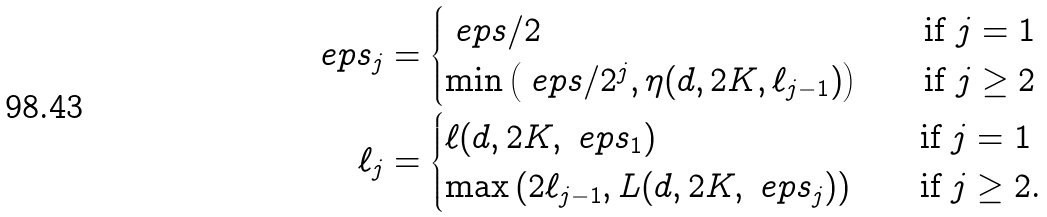Convert formula to latex. <formula><loc_0><loc_0><loc_500><loc_500>\ e p s _ { j } & = \begin{cases} \ e p s / 2 & \quad \text {if $j=1$} \\ \min \left ( \ e p s / 2 ^ { j } , \eta ( d , 2 K , \ell _ { j - 1 } ) \right ) & \quad \text {if $j\geq 2$} \end{cases} \\ \ell _ { j } & = \begin{cases} \ell ( d , 2 K , \ e p s _ { 1 } ) & \quad \text {if $j=1$} \\ \max \left ( 2 \ell _ { j - 1 } , L ( d , 2 K , \ e p s _ { j } ) \right ) & \quad \text {if $j \geq 2$.} \end{cases}</formula> 